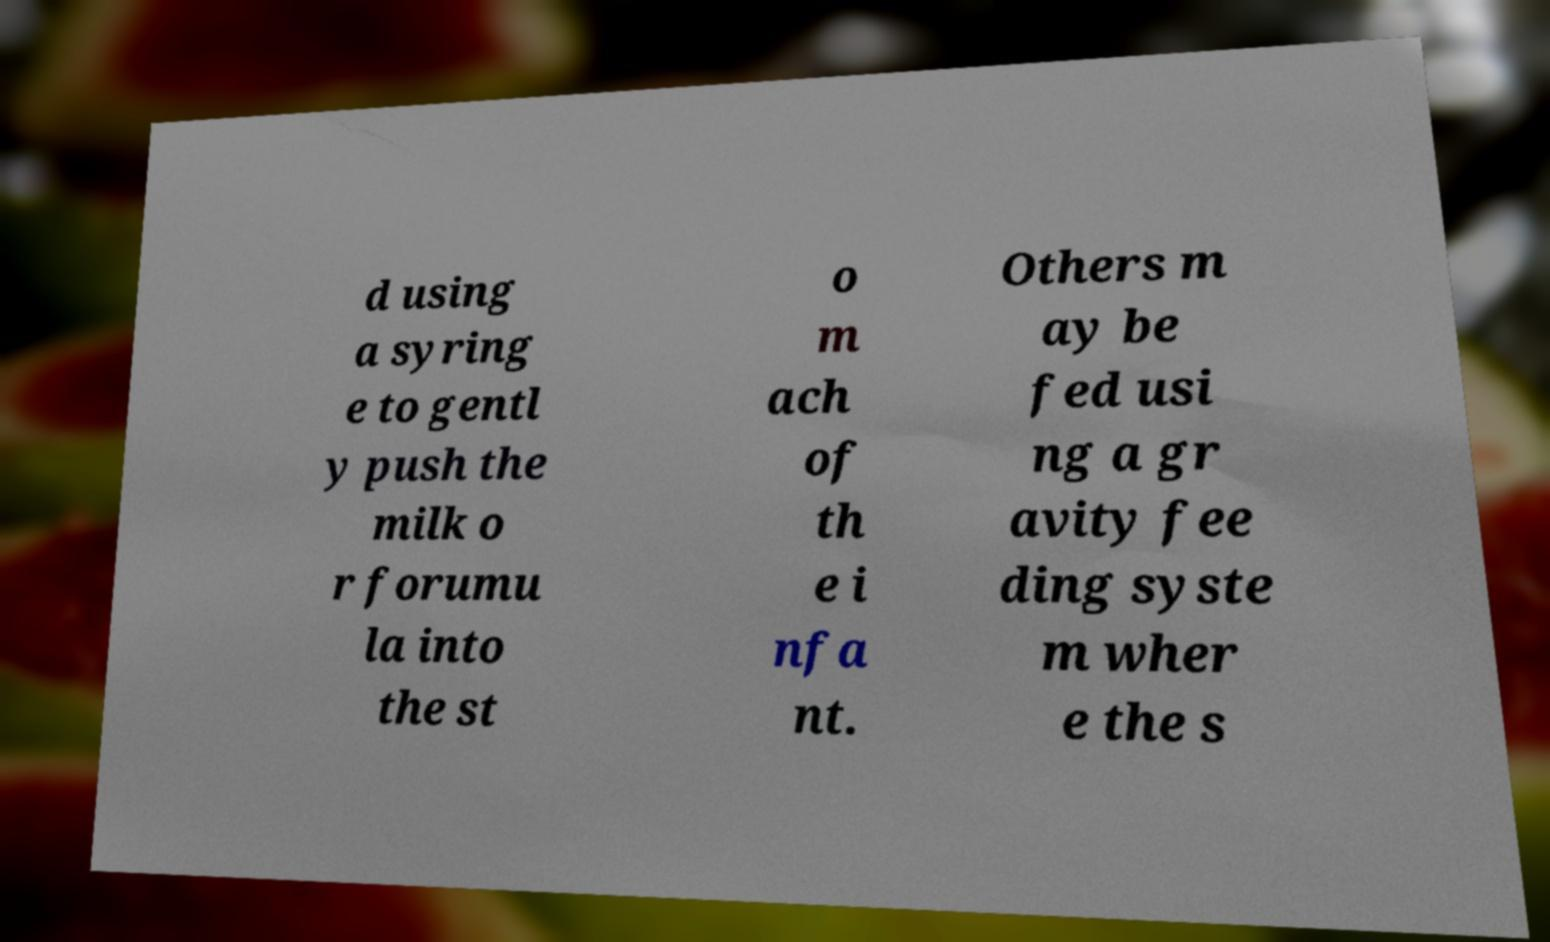What messages or text are displayed in this image? I need them in a readable, typed format. d using a syring e to gentl y push the milk o r forumu la into the st o m ach of th e i nfa nt. Others m ay be fed usi ng a gr avity fee ding syste m wher e the s 